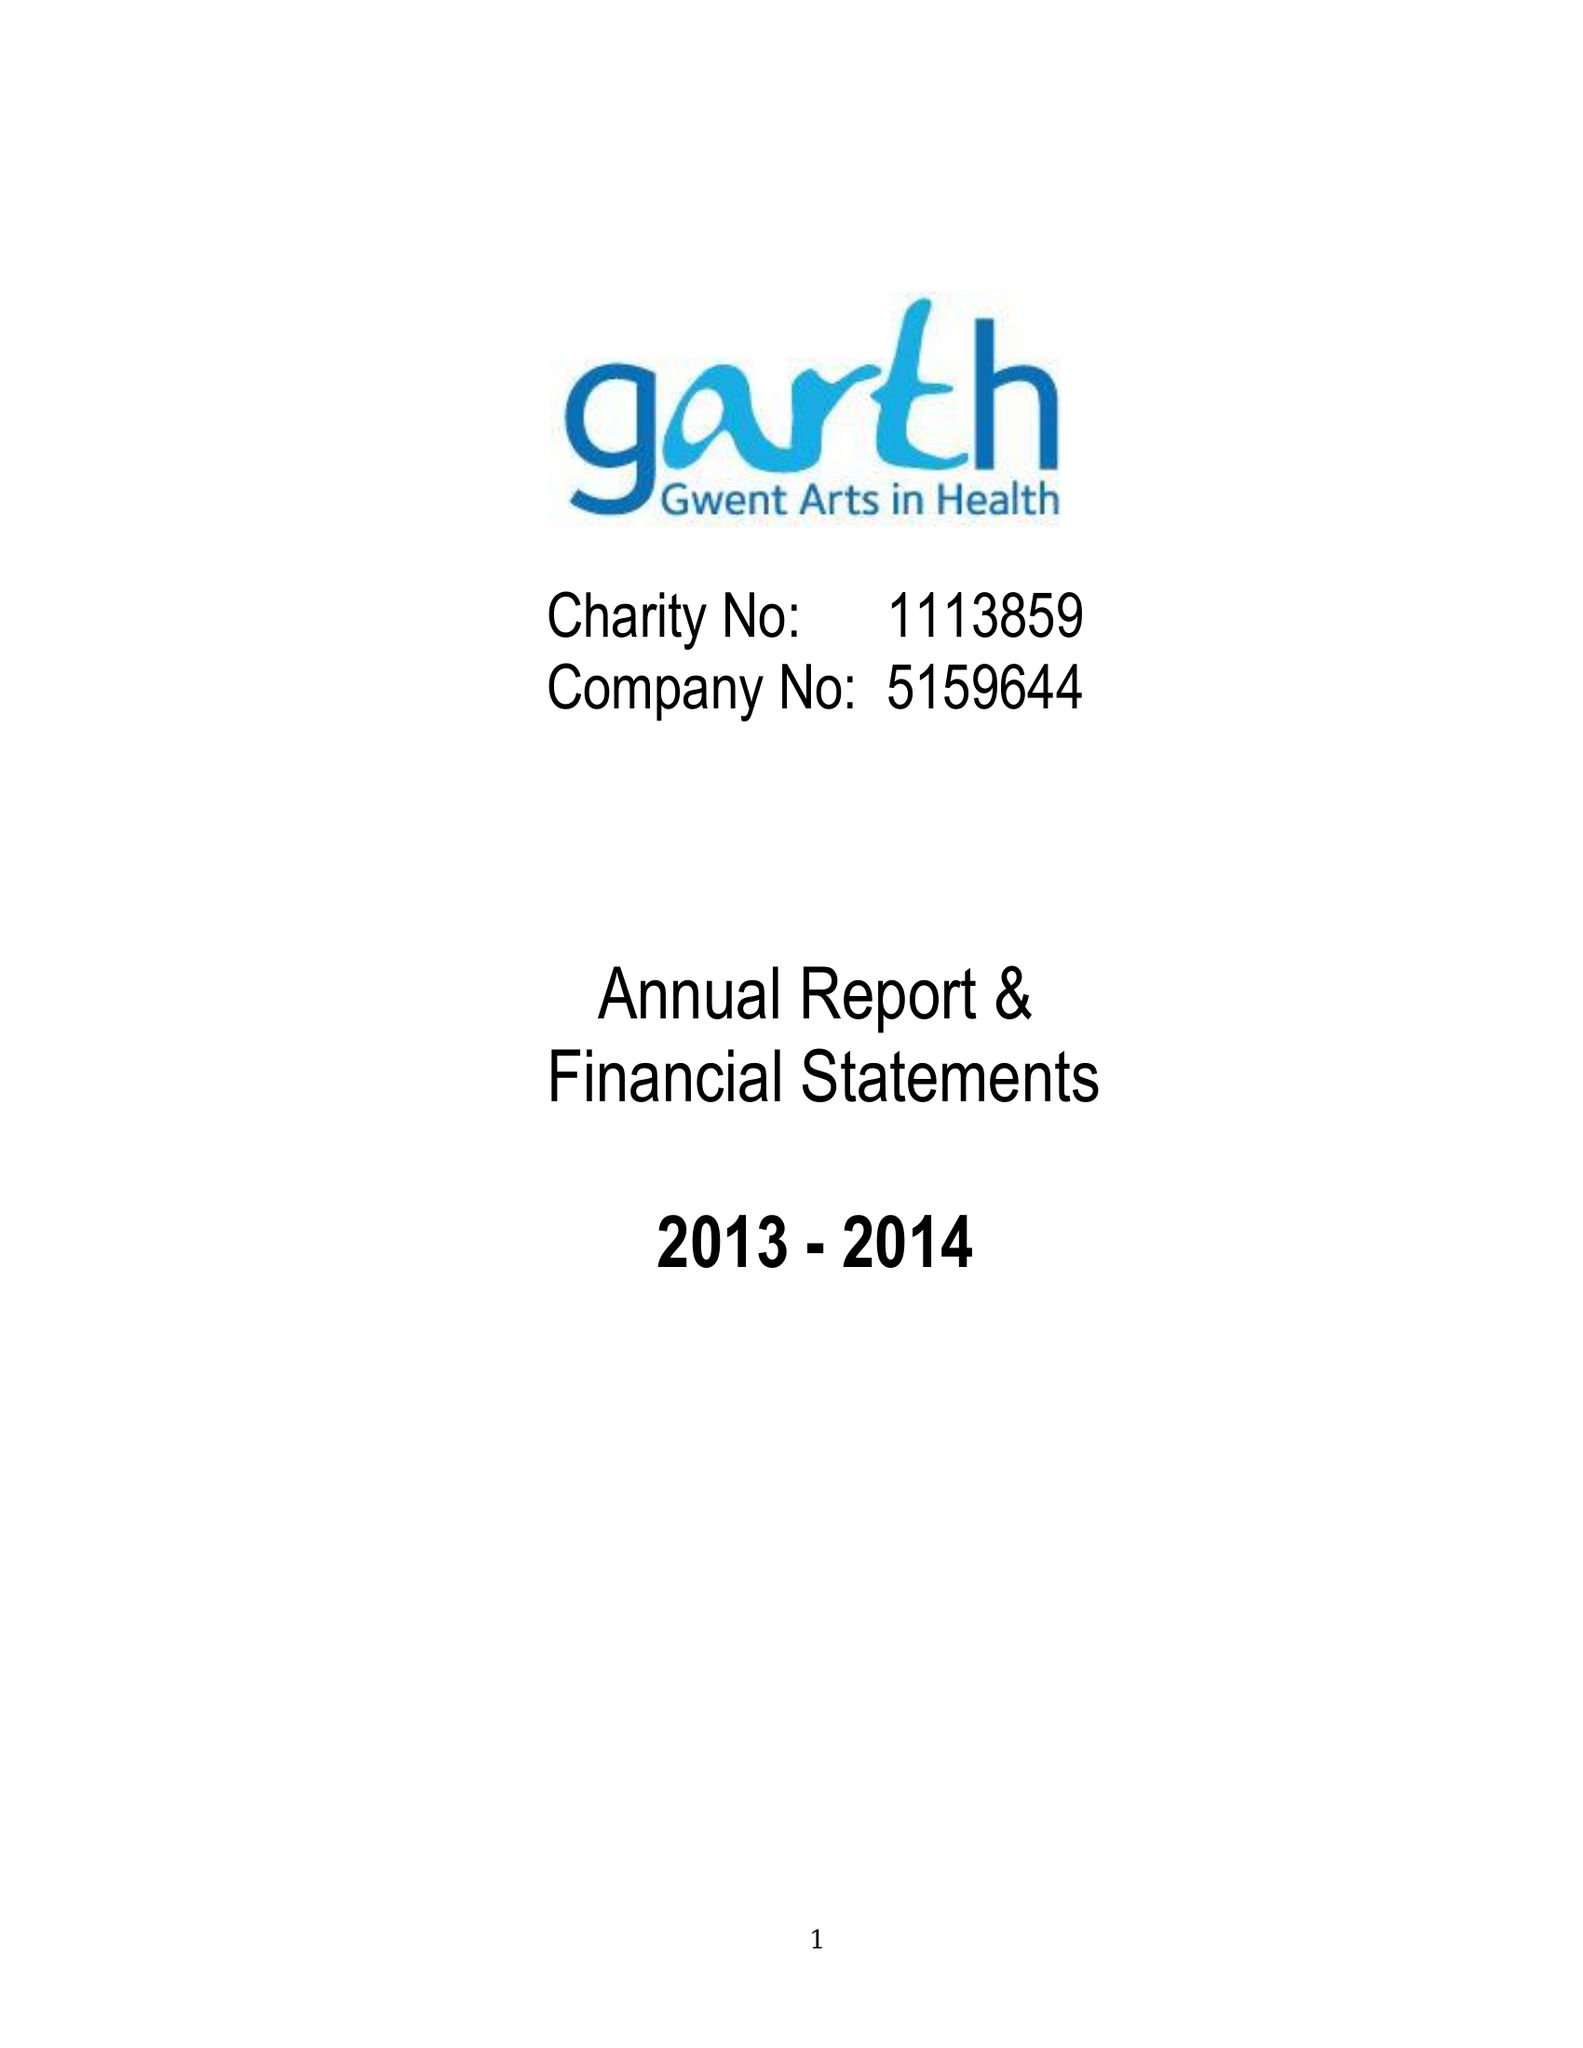What is the value for the address__postcode?
Answer the question using a single word or phrase. NP20 2UB 